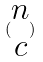Convert formula to latex. <formula><loc_0><loc_0><loc_500><loc_500>( \begin{matrix} n \\ c \end{matrix} )</formula> 